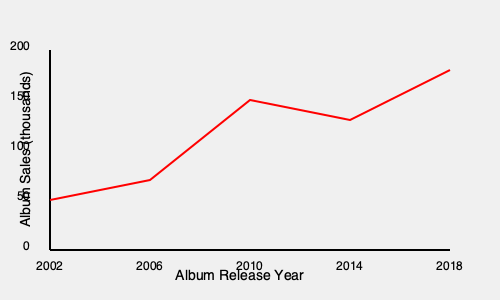Based on the album sales chart for Mucc, calculate the average rate of change in album sales (in thousands per year) between 2010 and 2014. To calculate the average rate of change in album sales between 2010 and 2014, we need to follow these steps:

1. Identify the album sales values for 2010 and 2014:
   - 2010: approximately 150,000 sales
   - 2014: approximately 130,000 sales

2. Calculate the change in sales:
   $\Delta y = 130,000 - 150,000 = -20,000$

3. Calculate the time interval:
   $\Delta x = 2014 - 2010 = 4$ years

4. Apply the average rate of change formula:
   Average rate of change = $\frac{\Delta y}{\Delta x}$

5. Substitute the values:
   Average rate of change = $\frac{-20,000}{4}$ = $-5,000$ per year

6. Convert to thousands per year:
   $-5,000$ per year = $-5$ thousand per year

Therefore, the average rate of change in album sales between 2010 and 2014 is $-5$ thousand per year.
Answer: $-5$ thousand per year 